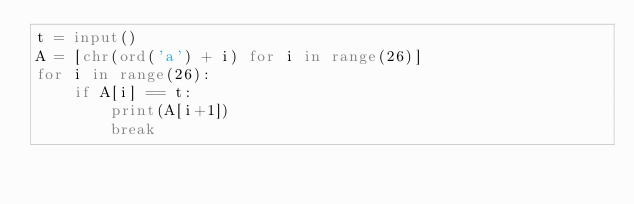<code> <loc_0><loc_0><loc_500><loc_500><_Python_>t = input()
A = [chr(ord('a') + i) for i in range(26)]
for i in range(26):
    if A[i] == t:
        print(A[i+1])
        break
</code> 